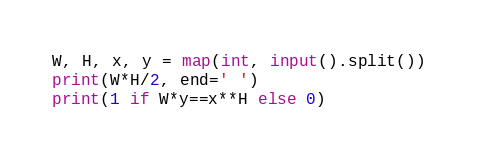<code> <loc_0><loc_0><loc_500><loc_500><_Python_>W, H, x, y = map(int, input().split())
print(W*H/2, end=' ')
print(1 if W*y==x**H else 0)</code> 